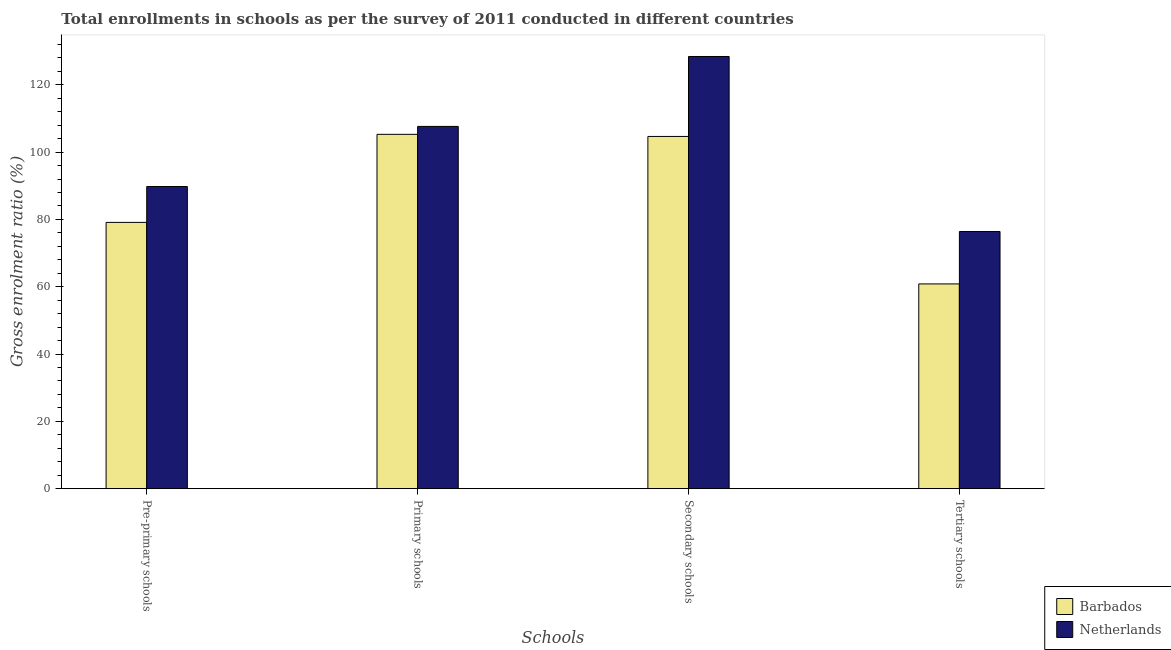Are the number of bars on each tick of the X-axis equal?
Offer a terse response. Yes. How many bars are there on the 2nd tick from the left?
Give a very brief answer. 2. What is the label of the 1st group of bars from the left?
Give a very brief answer. Pre-primary schools. What is the gross enrolment ratio in secondary schools in Netherlands?
Give a very brief answer. 128.42. Across all countries, what is the maximum gross enrolment ratio in tertiary schools?
Keep it short and to the point. 76.42. Across all countries, what is the minimum gross enrolment ratio in secondary schools?
Your answer should be very brief. 104.66. In which country was the gross enrolment ratio in secondary schools minimum?
Keep it short and to the point. Barbados. What is the total gross enrolment ratio in tertiary schools in the graph?
Offer a very short reply. 137.26. What is the difference between the gross enrolment ratio in tertiary schools in Barbados and that in Netherlands?
Offer a very short reply. -15.57. What is the difference between the gross enrolment ratio in secondary schools in Netherlands and the gross enrolment ratio in pre-primary schools in Barbados?
Offer a terse response. 49.3. What is the average gross enrolment ratio in tertiary schools per country?
Keep it short and to the point. 68.63. What is the difference between the gross enrolment ratio in primary schools and gross enrolment ratio in tertiary schools in Barbados?
Ensure brevity in your answer.  44.44. In how many countries, is the gross enrolment ratio in pre-primary schools greater than 104 %?
Provide a succinct answer. 0. What is the ratio of the gross enrolment ratio in secondary schools in Netherlands to that in Barbados?
Your answer should be compact. 1.23. Is the gross enrolment ratio in tertiary schools in Barbados less than that in Netherlands?
Your answer should be compact. Yes. What is the difference between the highest and the second highest gross enrolment ratio in secondary schools?
Ensure brevity in your answer.  23.76. What is the difference between the highest and the lowest gross enrolment ratio in primary schools?
Keep it short and to the point. 2.35. Is the sum of the gross enrolment ratio in pre-primary schools in Netherlands and Barbados greater than the maximum gross enrolment ratio in secondary schools across all countries?
Your answer should be very brief. Yes. What does the 2nd bar from the left in Pre-primary schools represents?
Your response must be concise. Netherlands. What does the 1st bar from the right in Secondary schools represents?
Ensure brevity in your answer.  Netherlands. Are all the bars in the graph horizontal?
Ensure brevity in your answer.  No. What is the difference between two consecutive major ticks on the Y-axis?
Ensure brevity in your answer.  20. What is the title of the graph?
Keep it short and to the point. Total enrollments in schools as per the survey of 2011 conducted in different countries. Does "Malaysia" appear as one of the legend labels in the graph?
Make the answer very short. No. What is the label or title of the X-axis?
Your answer should be very brief. Schools. What is the label or title of the Y-axis?
Your answer should be compact. Gross enrolment ratio (%). What is the Gross enrolment ratio (%) of Barbados in Pre-primary schools?
Ensure brevity in your answer.  79.12. What is the Gross enrolment ratio (%) in Netherlands in Pre-primary schools?
Provide a succinct answer. 89.78. What is the Gross enrolment ratio (%) in Barbados in Primary schools?
Make the answer very short. 105.29. What is the Gross enrolment ratio (%) of Netherlands in Primary schools?
Give a very brief answer. 107.64. What is the Gross enrolment ratio (%) of Barbados in Secondary schools?
Give a very brief answer. 104.66. What is the Gross enrolment ratio (%) in Netherlands in Secondary schools?
Make the answer very short. 128.42. What is the Gross enrolment ratio (%) of Barbados in Tertiary schools?
Offer a very short reply. 60.84. What is the Gross enrolment ratio (%) in Netherlands in Tertiary schools?
Ensure brevity in your answer.  76.42. Across all Schools, what is the maximum Gross enrolment ratio (%) in Barbados?
Offer a terse response. 105.29. Across all Schools, what is the maximum Gross enrolment ratio (%) in Netherlands?
Your answer should be very brief. 128.42. Across all Schools, what is the minimum Gross enrolment ratio (%) of Barbados?
Provide a short and direct response. 60.84. Across all Schools, what is the minimum Gross enrolment ratio (%) in Netherlands?
Give a very brief answer. 76.42. What is the total Gross enrolment ratio (%) in Barbados in the graph?
Keep it short and to the point. 349.91. What is the total Gross enrolment ratio (%) of Netherlands in the graph?
Your response must be concise. 402.25. What is the difference between the Gross enrolment ratio (%) of Barbados in Pre-primary schools and that in Primary schools?
Your answer should be very brief. -26.16. What is the difference between the Gross enrolment ratio (%) in Netherlands in Pre-primary schools and that in Primary schools?
Your response must be concise. -17.86. What is the difference between the Gross enrolment ratio (%) in Barbados in Pre-primary schools and that in Secondary schools?
Your response must be concise. -25.54. What is the difference between the Gross enrolment ratio (%) in Netherlands in Pre-primary schools and that in Secondary schools?
Provide a short and direct response. -38.64. What is the difference between the Gross enrolment ratio (%) in Barbados in Pre-primary schools and that in Tertiary schools?
Provide a succinct answer. 18.28. What is the difference between the Gross enrolment ratio (%) of Netherlands in Pre-primary schools and that in Tertiary schools?
Keep it short and to the point. 13.37. What is the difference between the Gross enrolment ratio (%) in Barbados in Primary schools and that in Secondary schools?
Ensure brevity in your answer.  0.63. What is the difference between the Gross enrolment ratio (%) in Netherlands in Primary schools and that in Secondary schools?
Provide a short and direct response. -20.78. What is the difference between the Gross enrolment ratio (%) of Barbados in Primary schools and that in Tertiary schools?
Keep it short and to the point. 44.44. What is the difference between the Gross enrolment ratio (%) of Netherlands in Primary schools and that in Tertiary schools?
Offer a very short reply. 31.22. What is the difference between the Gross enrolment ratio (%) of Barbados in Secondary schools and that in Tertiary schools?
Give a very brief answer. 43.82. What is the difference between the Gross enrolment ratio (%) of Netherlands in Secondary schools and that in Tertiary schools?
Your answer should be very brief. 52. What is the difference between the Gross enrolment ratio (%) in Barbados in Pre-primary schools and the Gross enrolment ratio (%) in Netherlands in Primary schools?
Give a very brief answer. -28.52. What is the difference between the Gross enrolment ratio (%) of Barbados in Pre-primary schools and the Gross enrolment ratio (%) of Netherlands in Secondary schools?
Ensure brevity in your answer.  -49.3. What is the difference between the Gross enrolment ratio (%) in Barbados in Pre-primary schools and the Gross enrolment ratio (%) in Netherlands in Tertiary schools?
Make the answer very short. 2.71. What is the difference between the Gross enrolment ratio (%) of Barbados in Primary schools and the Gross enrolment ratio (%) of Netherlands in Secondary schools?
Offer a very short reply. -23.13. What is the difference between the Gross enrolment ratio (%) in Barbados in Primary schools and the Gross enrolment ratio (%) in Netherlands in Tertiary schools?
Provide a succinct answer. 28.87. What is the difference between the Gross enrolment ratio (%) of Barbados in Secondary schools and the Gross enrolment ratio (%) of Netherlands in Tertiary schools?
Your answer should be compact. 28.24. What is the average Gross enrolment ratio (%) of Barbados per Schools?
Offer a very short reply. 87.48. What is the average Gross enrolment ratio (%) of Netherlands per Schools?
Provide a short and direct response. 100.56. What is the difference between the Gross enrolment ratio (%) in Barbados and Gross enrolment ratio (%) in Netherlands in Pre-primary schools?
Keep it short and to the point. -10.66. What is the difference between the Gross enrolment ratio (%) in Barbados and Gross enrolment ratio (%) in Netherlands in Primary schools?
Ensure brevity in your answer.  -2.35. What is the difference between the Gross enrolment ratio (%) of Barbados and Gross enrolment ratio (%) of Netherlands in Secondary schools?
Offer a terse response. -23.76. What is the difference between the Gross enrolment ratio (%) in Barbados and Gross enrolment ratio (%) in Netherlands in Tertiary schools?
Ensure brevity in your answer.  -15.57. What is the ratio of the Gross enrolment ratio (%) of Barbados in Pre-primary schools to that in Primary schools?
Make the answer very short. 0.75. What is the ratio of the Gross enrolment ratio (%) in Netherlands in Pre-primary schools to that in Primary schools?
Give a very brief answer. 0.83. What is the ratio of the Gross enrolment ratio (%) of Barbados in Pre-primary schools to that in Secondary schools?
Offer a very short reply. 0.76. What is the ratio of the Gross enrolment ratio (%) in Netherlands in Pre-primary schools to that in Secondary schools?
Make the answer very short. 0.7. What is the ratio of the Gross enrolment ratio (%) in Barbados in Pre-primary schools to that in Tertiary schools?
Ensure brevity in your answer.  1.3. What is the ratio of the Gross enrolment ratio (%) of Netherlands in Pre-primary schools to that in Tertiary schools?
Provide a succinct answer. 1.17. What is the ratio of the Gross enrolment ratio (%) of Netherlands in Primary schools to that in Secondary schools?
Keep it short and to the point. 0.84. What is the ratio of the Gross enrolment ratio (%) in Barbados in Primary schools to that in Tertiary schools?
Your answer should be compact. 1.73. What is the ratio of the Gross enrolment ratio (%) in Netherlands in Primary schools to that in Tertiary schools?
Provide a short and direct response. 1.41. What is the ratio of the Gross enrolment ratio (%) of Barbados in Secondary schools to that in Tertiary schools?
Give a very brief answer. 1.72. What is the ratio of the Gross enrolment ratio (%) in Netherlands in Secondary schools to that in Tertiary schools?
Your answer should be compact. 1.68. What is the difference between the highest and the second highest Gross enrolment ratio (%) of Barbados?
Your response must be concise. 0.63. What is the difference between the highest and the second highest Gross enrolment ratio (%) of Netherlands?
Your response must be concise. 20.78. What is the difference between the highest and the lowest Gross enrolment ratio (%) in Barbados?
Keep it short and to the point. 44.44. What is the difference between the highest and the lowest Gross enrolment ratio (%) of Netherlands?
Provide a short and direct response. 52. 